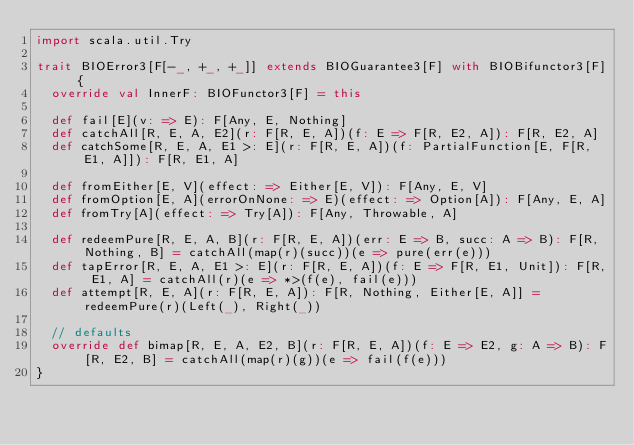<code> <loc_0><loc_0><loc_500><loc_500><_Scala_>import scala.util.Try

trait BIOError3[F[-_, +_, +_]] extends BIOGuarantee3[F] with BIOBifunctor3[F] {
  override val InnerF: BIOFunctor3[F] = this

  def fail[E](v: => E): F[Any, E, Nothing]
  def catchAll[R, E, A, E2](r: F[R, E, A])(f: E => F[R, E2, A]): F[R, E2, A]
  def catchSome[R, E, A, E1 >: E](r: F[R, E, A])(f: PartialFunction[E, F[R, E1, A]]): F[R, E1, A]

  def fromEither[E, V](effect: => Either[E, V]): F[Any, E, V]
  def fromOption[E, A](errorOnNone: => E)(effect: => Option[A]): F[Any, E, A]
  def fromTry[A](effect: => Try[A]): F[Any, Throwable, A]

  def redeemPure[R, E, A, B](r: F[R, E, A])(err: E => B, succ: A => B): F[R, Nothing, B] = catchAll(map(r)(succ))(e => pure(err(e)))
  def tapError[R, E, A, E1 >: E](r: F[R, E, A])(f: E => F[R, E1, Unit]): F[R, E1, A] = catchAll(r)(e => *>(f(e), fail(e)))
  def attempt[R, E, A](r: F[R, E, A]): F[R, Nothing, Either[E, A]] = redeemPure(r)(Left(_), Right(_))

  // defaults
  override def bimap[R, E, A, E2, B](r: F[R, E, A])(f: E => E2, g: A => B): F[R, E2, B] = catchAll(map(r)(g))(e => fail(f(e)))
}
</code> 